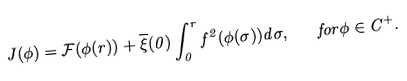<formula> <loc_0><loc_0><loc_500><loc_500>J ( \phi ) = \mathcal { F } ( \phi ( r ) ) + \overline { \xi } ( 0 ) \int _ { 0 } ^ { r } f ^ { 2 } ( \phi ( \sigma ) ) d \sigma , \quad f o r \phi \in C ^ { + } .</formula> 